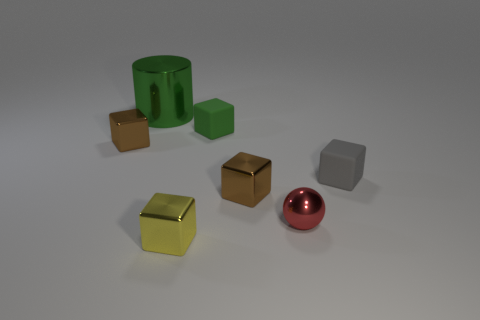There is a cube that is the same color as the cylinder; what is it made of?
Give a very brief answer. Rubber. There is a shiny thing that is left of the small yellow object and in front of the green metal thing; what size is it?
Give a very brief answer. Small. There is a yellow thing that is the same shape as the small green matte object; what is it made of?
Give a very brief answer. Metal. There is a object behind the small green object; is it the same color as the rubber object to the left of the tiny red thing?
Give a very brief answer. Yes. There is a tiny rubber thing on the right side of the red metallic ball; what shape is it?
Keep it short and to the point. Cube. What is the color of the big thing?
Your answer should be compact. Green. There is a green object that is made of the same material as the tiny yellow object; what is its shape?
Provide a succinct answer. Cylinder. Is the size of the brown metallic thing right of the green rubber thing the same as the green matte block?
Offer a terse response. Yes. How many things are tiny brown things on the right side of the small green block or metal things in front of the big green object?
Provide a short and direct response. 4. Does the tiny rubber thing that is behind the gray thing have the same color as the cylinder?
Offer a very short reply. Yes. 